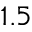<formula> <loc_0><loc_0><loc_500><loc_500>1 . 5</formula> 